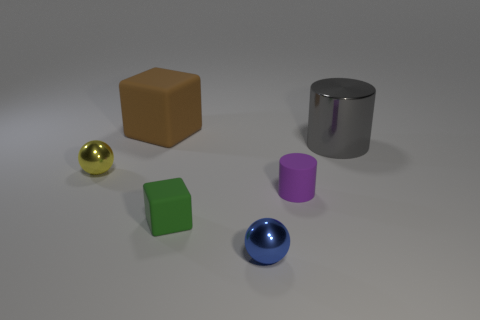Add 3 small blue shiny objects. How many objects exist? 9 Subtract all balls. How many objects are left? 4 Subtract all big brown cubes. Subtract all large objects. How many objects are left? 3 Add 6 small purple rubber cylinders. How many small purple rubber cylinders are left? 7 Add 4 green things. How many green things exist? 5 Subtract 1 purple cylinders. How many objects are left? 5 